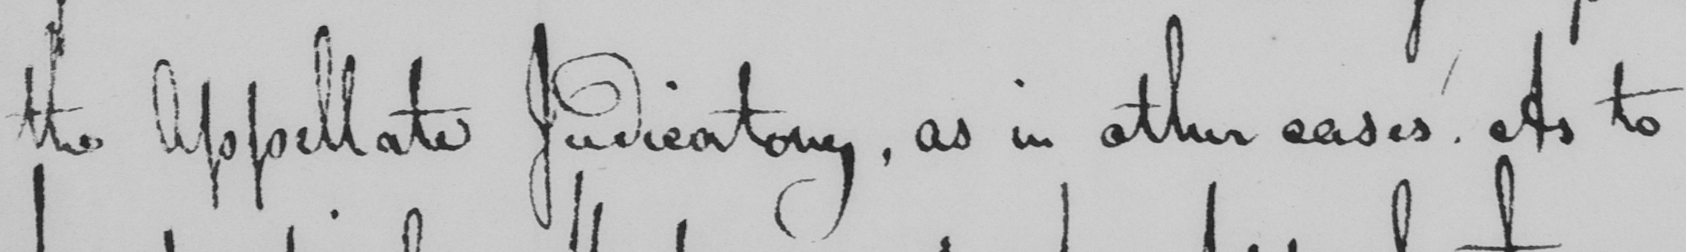Please transcribe the handwritten text in this image. the Appellate Judicatory , as in other cases . As to 